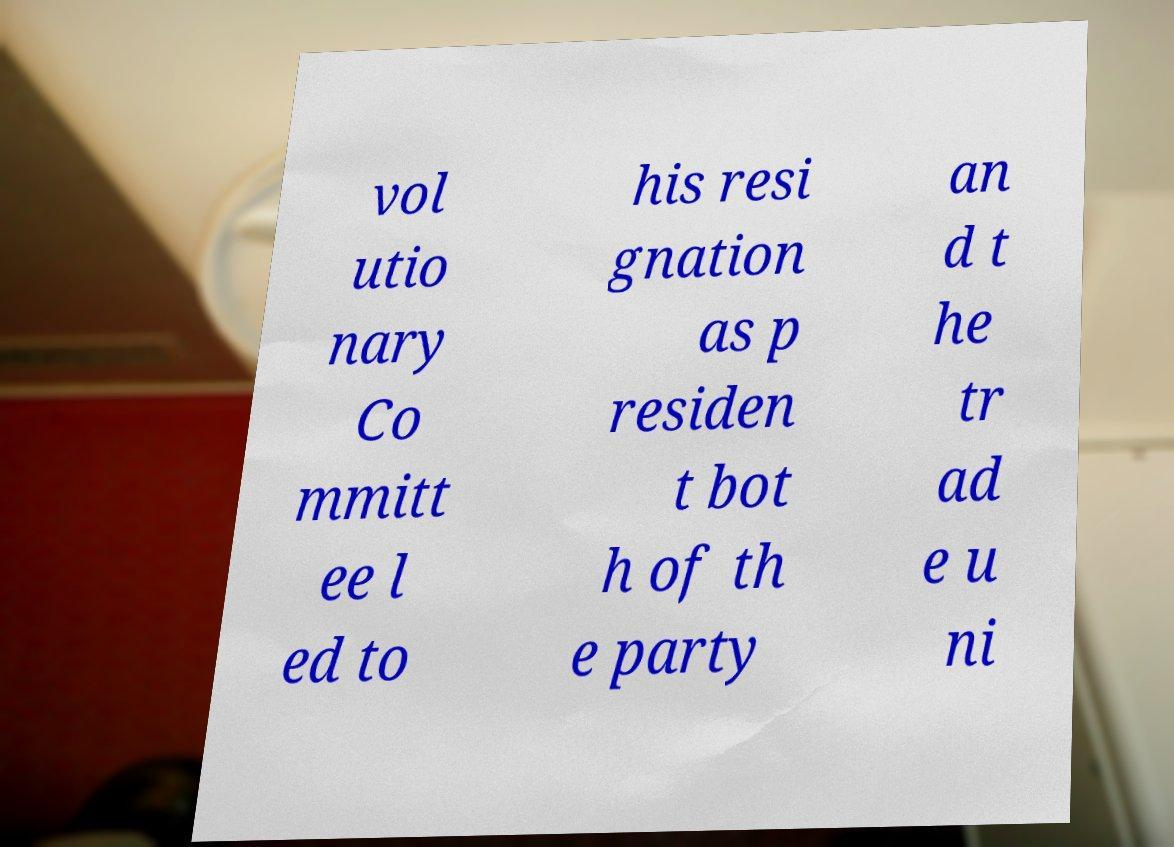Please read and relay the text visible in this image. What does it say? vol utio nary Co mmitt ee l ed to his resi gnation as p residen t bot h of th e party an d t he tr ad e u ni 